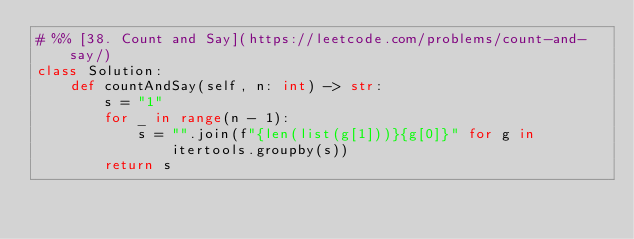Convert code to text. <code><loc_0><loc_0><loc_500><loc_500><_Python_># %% [38. Count and Say](https://leetcode.com/problems/count-and-say/)
class Solution:
    def countAndSay(self, n: int) -> str:
        s = "1"
        for _ in range(n - 1):
            s = "".join(f"{len(list(g[1]))}{g[0]}" for g in itertools.groupby(s))
        return s
</code> 